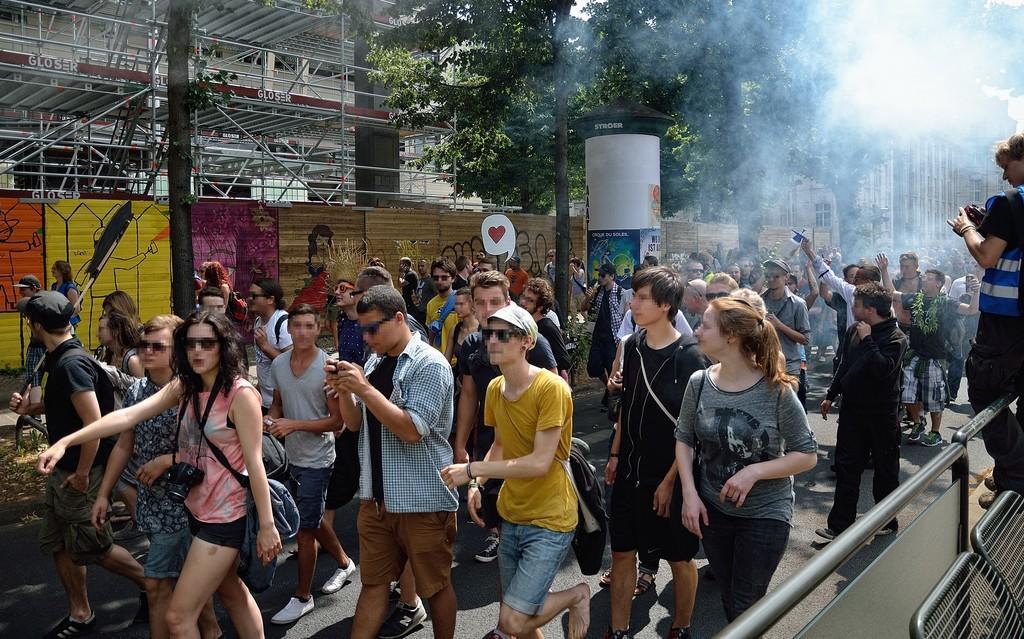Could you give a brief overview of what you see in this image? In this picture we can see a few people on the path. We can see barricades and a person is holding an object on the right side. We can see a few paintings and posters on the left side. There are a few trees and buildings visible in the background. 